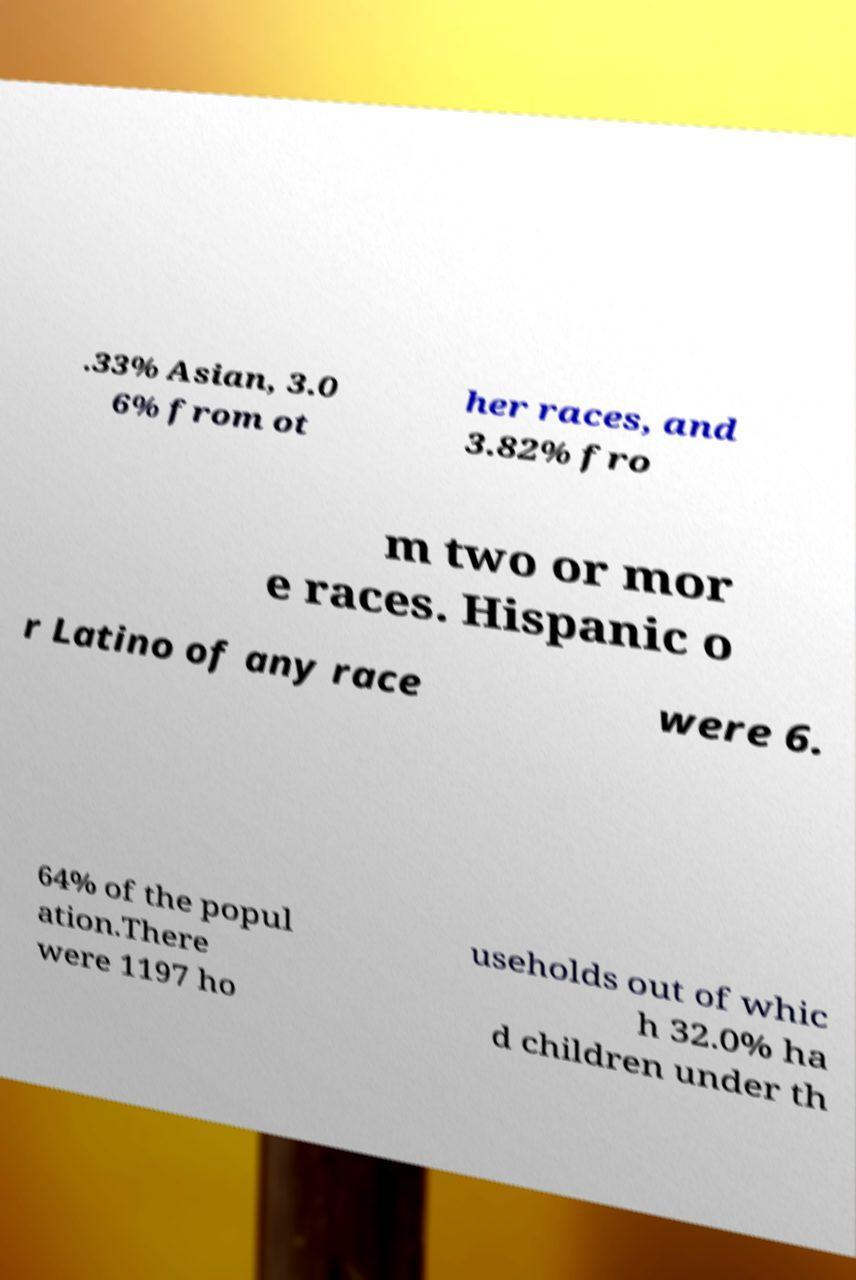Can you read and provide the text displayed in the image?This photo seems to have some interesting text. Can you extract and type it out for me? .33% Asian, 3.0 6% from ot her races, and 3.82% fro m two or mor e races. Hispanic o r Latino of any race were 6. 64% of the popul ation.There were 1197 ho useholds out of whic h 32.0% ha d children under th 